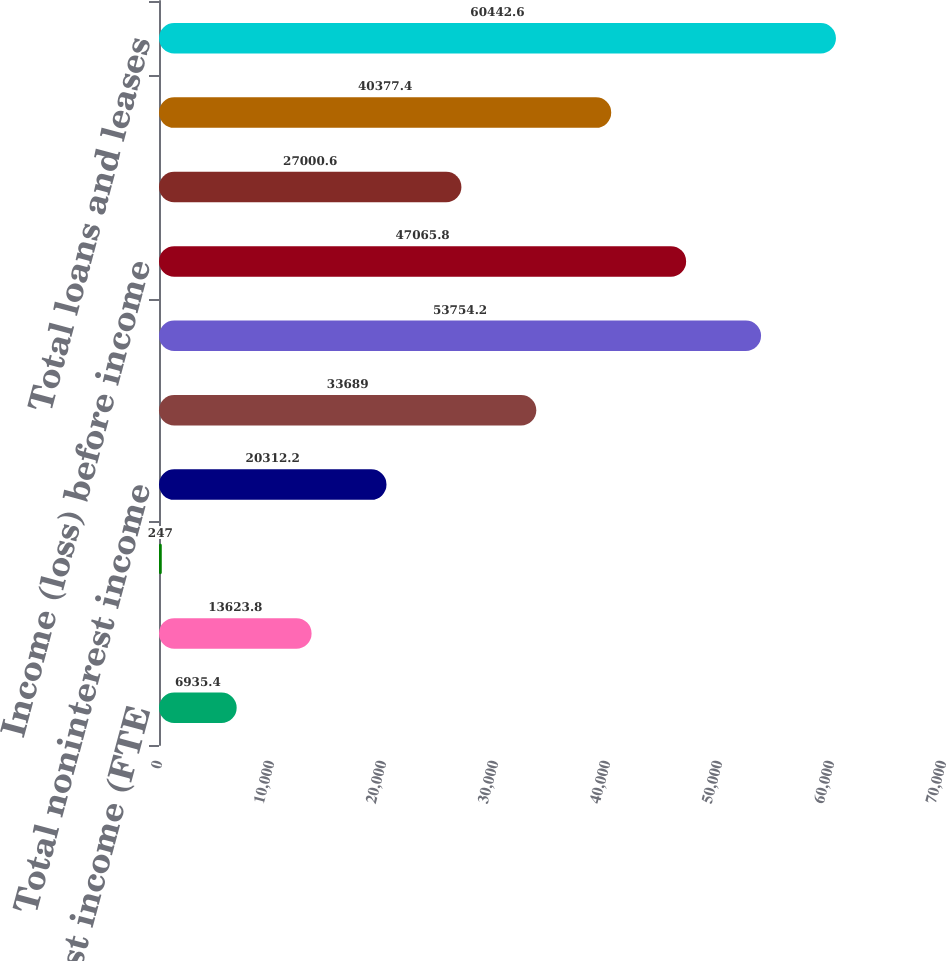Convert chart. <chart><loc_0><loc_0><loc_500><loc_500><bar_chart><fcel>Net interest income (FTE<fcel>Mortgage banking income<fcel>All other income (loss)<fcel>Total noninterest income<fcel>Total revenue net of interest<fcel>Noninterest expense<fcel>Income (loss) before income<fcel>Income tax expense (benefit)<fcel>Net income (loss)<fcel>Total loans and leases<nl><fcel>6935.4<fcel>13623.8<fcel>247<fcel>20312.2<fcel>33689<fcel>53754.2<fcel>47065.8<fcel>27000.6<fcel>40377.4<fcel>60442.6<nl></chart> 